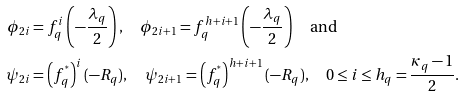Convert formula to latex. <formula><loc_0><loc_0><loc_500><loc_500>\phi _ { 2 i } & = f _ { q } ^ { i } \left ( - \frac { \lambda _ { q } } { 2 } \right ) , \quad \phi _ { 2 i + 1 } = f _ { q } ^ { h + i + 1 } \left ( - \frac { \lambda _ { q } } { 2 } \right ) \quad \text {and} \\ \psi _ { 2 i } & = \left ( f _ { q } ^ { ^ { * } } \right ) ^ { i } ( - R _ { q } ) , \quad \psi _ { 2 i + 1 } = \left ( f _ { q } ^ { ^ { * } } \right ) ^ { h + i + 1 } ( - R _ { q } ) , \quad 0 \leq i \leq h _ { q } = \frac { { \kappa _ { q } } - 1 } { 2 } .</formula> 